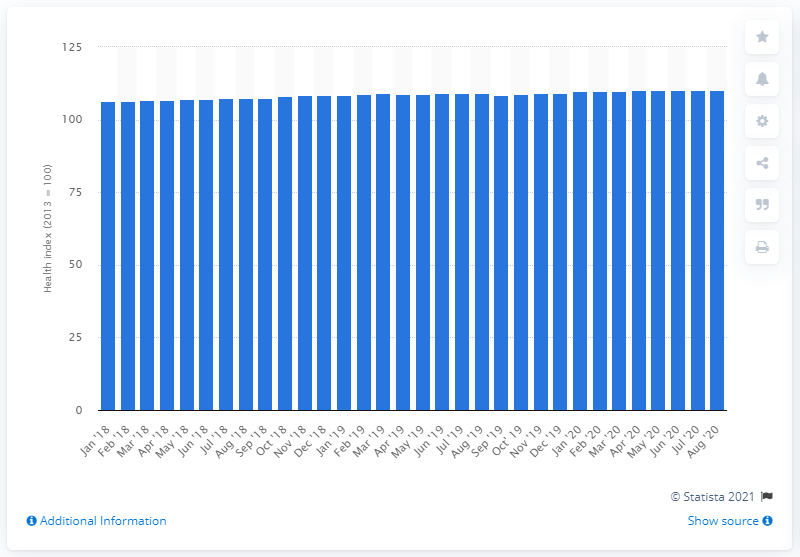Identify some key points in this picture. In August 2020, the highest value of the health index was 110.2. 